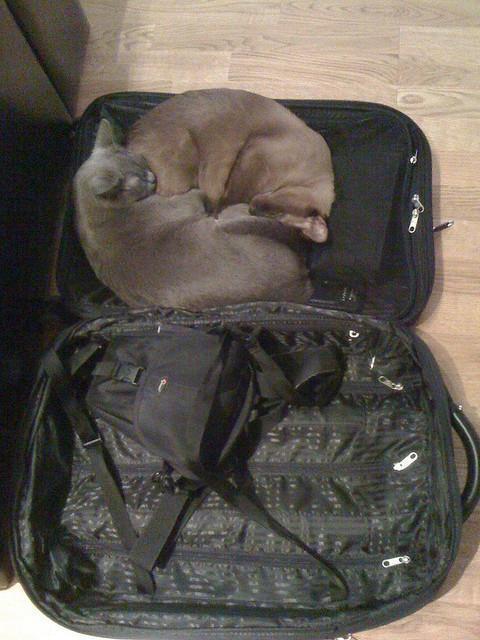How many cats can you see?
Give a very brief answer. 2. 